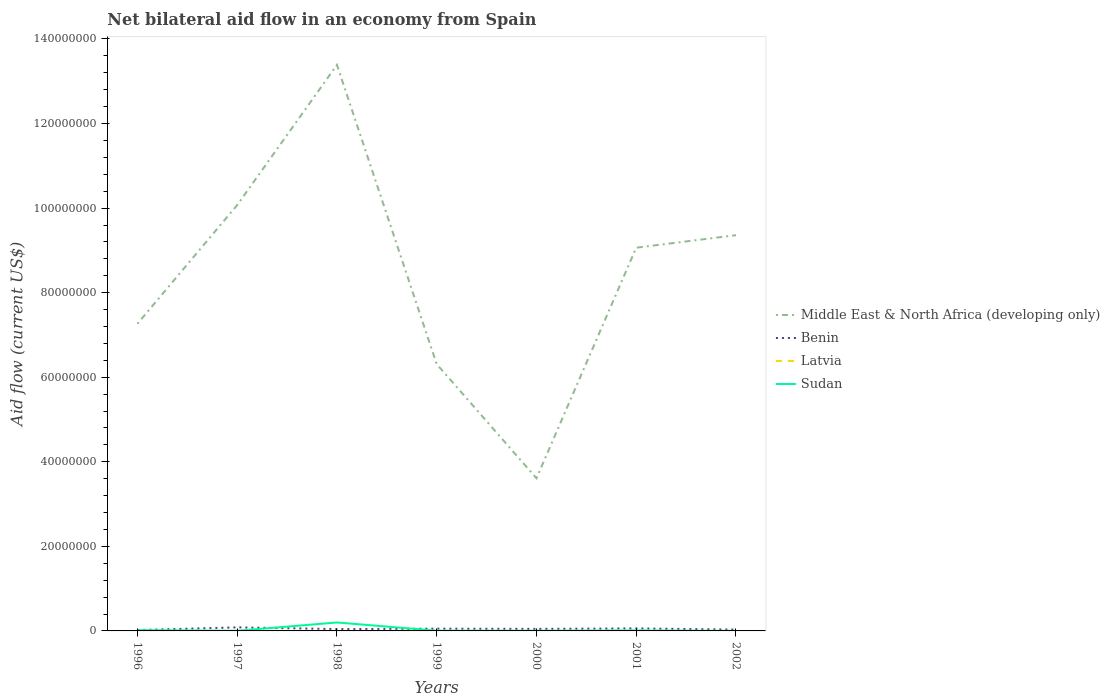How many different coloured lines are there?
Ensure brevity in your answer.  4. Across all years, what is the maximum net bilateral aid flow in Latvia?
Offer a very short reply. 10000. What is the total net bilateral aid flow in Middle East & North Africa (developing only) in the graph?
Offer a very short reply. 4.32e+07. What is the difference between the highest and the second highest net bilateral aid flow in Benin?
Offer a very short reply. 6.40e+05. How many lines are there?
Ensure brevity in your answer.  4. How many years are there in the graph?
Make the answer very short. 7. Does the graph contain grids?
Your answer should be very brief. No. Where does the legend appear in the graph?
Your response must be concise. Center right. What is the title of the graph?
Ensure brevity in your answer.  Net bilateral aid flow in an economy from Spain. Does "Central African Republic" appear as one of the legend labels in the graph?
Your response must be concise. No. What is the label or title of the X-axis?
Make the answer very short. Years. What is the label or title of the Y-axis?
Ensure brevity in your answer.  Aid flow (current US$). What is the Aid flow (current US$) in Middle East & North Africa (developing only) in 1996?
Your response must be concise. 7.26e+07. What is the Aid flow (current US$) in Sudan in 1996?
Offer a terse response. 1.80e+05. What is the Aid flow (current US$) in Middle East & North Africa (developing only) in 1997?
Your response must be concise. 1.01e+08. What is the Aid flow (current US$) of Benin in 1997?
Your response must be concise. 8.40e+05. What is the Aid flow (current US$) in Latvia in 1997?
Offer a terse response. 10000. What is the Aid flow (current US$) of Middle East & North Africa (developing only) in 1998?
Give a very brief answer. 1.34e+08. What is the Aid flow (current US$) of Latvia in 1998?
Give a very brief answer. 10000. What is the Aid flow (current US$) of Sudan in 1998?
Ensure brevity in your answer.  2.00e+06. What is the Aid flow (current US$) of Middle East & North Africa (developing only) in 1999?
Offer a very short reply. 6.31e+07. What is the Aid flow (current US$) of Benin in 1999?
Offer a terse response. 5.30e+05. What is the Aid flow (current US$) of Middle East & North Africa (developing only) in 2000?
Offer a terse response. 3.61e+07. What is the Aid flow (current US$) of Benin in 2000?
Keep it short and to the point. 4.80e+05. What is the Aid flow (current US$) of Sudan in 2000?
Provide a short and direct response. 4.00e+04. What is the Aid flow (current US$) of Middle East & North Africa (developing only) in 2001?
Provide a short and direct response. 9.06e+07. What is the Aid flow (current US$) in Benin in 2001?
Provide a succinct answer. 5.90e+05. What is the Aid flow (current US$) in Latvia in 2001?
Offer a very short reply. 2.00e+04. What is the Aid flow (current US$) in Middle East & North Africa (developing only) in 2002?
Your response must be concise. 9.36e+07. What is the Aid flow (current US$) of Benin in 2002?
Provide a succinct answer. 3.20e+05. What is the Aid flow (current US$) in Sudan in 2002?
Provide a short and direct response. 10000. Across all years, what is the maximum Aid flow (current US$) in Middle East & North Africa (developing only)?
Your answer should be very brief. 1.34e+08. Across all years, what is the maximum Aid flow (current US$) in Benin?
Ensure brevity in your answer.  8.40e+05. Across all years, what is the maximum Aid flow (current US$) of Latvia?
Give a very brief answer. 2.00e+04. Across all years, what is the minimum Aid flow (current US$) of Middle East & North Africa (developing only)?
Your answer should be compact. 3.61e+07. Across all years, what is the minimum Aid flow (current US$) of Sudan?
Provide a succinct answer. 10000. What is the total Aid flow (current US$) in Middle East & North Africa (developing only) in the graph?
Your answer should be very brief. 5.91e+08. What is the total Aid flow (current US$) in Benin in the graph?
Your answer should be very brief. 3.39e+06. What is the total Aid flow (current US$) in Sudan in the graph?
Ensure brevity in your answer.  2.41e+06. What is the difference between the Aid flow (current US$) of Middle East & North Africa (developing only) in 1996 and that in 1997?
Ensure brevity in your answer.  -2.81e+07. What is the difference between the Aid flow (current US$) of Benin in 1996 and that in 1997?
Keep it short and to the point. -6.40e+05. What is the difference between the Aid flow (current US$) of Latvia in 1996 and that in 1997?
Provide a succinct answer. 0. What is the difference between the Aid flow (current US$) in Sudan in 1996 and that in 1997?
Your answer should be compact. 1.50e+05. What is the difference between the Aid flow (current US$) of Middle East & North Africa (developing only) in 1996 and that in 1998?
Keep it short and to the point. -6.12e+07. What is the difference between the Aid flow (current US$) in Benin in 1996 and that in 1998?
Provide a succinct answer. -2.30e+05. What is the difference between the Aid flow (current US$) in Latvia in 1996 and that in 1998?
Your response must be concise. 0. What is the difference between the Aid flow (current US$) in Sudan in 1996 and that in 1998?
Offer a very short reply. -1.82e+06. What is the difference between the Aid flow (current US$) of Middle East & North Africa (developing only) in 1996 and that in 1999?
Offer a very short reply. 9.55e+06. What is the difference between the Aid flow (current US$) of Benin in 1996 and that in 1999?
Provide a succinct answer. -3.30e+05. What is the difference between the Aid flow (current US$) in Sudan in 1996 and that in 1999?
Provide a short and direct response. 1.30e+05. What is the difference between the Aid flow (current US$) in Middle East & North Africa (developing only) in 1996 and that in 2000?
Keep it short and to the point. 3.65e+07. What is the difference between the Aid flow (current US$) in Benin in 1996 and that in 2000?
Give a very brief answer. -2.80e+05. What is the difference between the Aid flow (current US$) of Latvia in 1996 and that in 2000?
Give a very brief answer. 0. What is the difference between the Aid flow (current US$) of Middle East & North Africa (developing only) in 1996 and that in 2001?
Your response must be concise. -1.80e+07. What is the difference between the Aid flow (current US$) of Benin in 1996 and that in 2001?
Offer a terse response. -3.90e+05. What is the difference between the Aid flow (current US$) of Latvia in 1996 and that in 2001?
Keep it short and to the point. -10000. What is the difference between the Aid flow (current US$) in Middle East & North Africa (developing only) in 1996 and that in 2002?
Your response must be concise. -2.10e+07. What is the difference between the Aid flow (current US$) in Middle East & North Africa (developing only) in 1997 and that in 1998?
Provide a short and direct response. -3.32e+07. What is the difference between the Aid flow (current US$) in Benin in 1997 and that in 1998?
Your answer should be compact. 4.10e+05. What is the difference between the Aid flow (current US$) in Sudan in 1997 and that in 1998?
Offer a terse response. -1.97e+06. What is the difference between the Aid flow (current US$) of Middle East & North Africa (developing only) in 1997 and that in 1999?
Your answer should be very brief. 3.76e+07. What is the difference between the Aid flow (current US$) of Benin in 1997 and that in 1999?
Offer a terse response. 3.10e+05. What is the difference between the Aid flow (current US$) of Middle East & North Africa (developing only) in 1997 and that in 2000?
Your answer should be compact. 6.46e+07. What is the difference between the Aid flow (current US$) of Middle East & North Africa (developing only) in 1997 and that in 2001?
Provide a succinct answer. 1.01e+07. What is the difference between the Aid flow (current US$) in Latvia in 1997 and that in 2001?
Provide a succinct answer. -10000. What is the difference between the Aid flow (current US$) in Sudan in 1997 and that in 2001?
Your answer should be very brief. -7.00e+04. What is the difference between the Aid flow (current US$) in Middle East & North Africa (developing only) in 1997 and that in 2002?
Your answer should be very brief. 7.12e+06. What is the difference between the Aid flow (current US$) in Benin in 1997 and that in 2002?
Your answer should be compact. 5.20e+05. What is the difference between the Aid flow (current US$) in Sudan in 1997 and that in 2002?
Your answer should be very brief. 2.00e+04. What is the difference between the Aid flow (current US$) of Middle East & North Africa (developing only) in 1998 and that in 1999?
Give a very brief answer. 7.08e+07. What is the difference between the Aid flow (current US$) of Benin in 1998 and that in 1999?
Your answer should be compact. -1.00e+05. What is the difference between the Aid flow (current US$) in Sudan in 1998 and that in 1999?
Make the answer very short. 1.95e+06. What is the difference between the Aid flow (current US$) of Middle East & North Africa (developing only) in 1998 and that in 2000?
Your response must be concise. 9.78e+07. What is the difference between the Aid flow (current US$) of Sudan in 1998 and that in 2000?
Your answer should be very brief. 1.96e+06. What is the difference between the Aid flow (current US$) in Middle East & North Africa (developing only) in 1998 and that in 2001?
Make the answer very short. 4.32e+07. What is the difference between the Aid flow (current US$) in Benin in 1998 and that in 2001?
Make the answer very short. -1.60e+05. What is the difference between the Aid flow (current US$) in Latvia in 1998 and that in 2001?
Provide a short and direct response. -10000. What is the difference between the Aid flow (current US$) of Sudan in 1998 and that in 2001?
Your response must be concise. 1.90e+06. What is the difference between the Aid flow (current US$) of Middle East & North Africa (developing only) in 1998 and that in 2002?
Provide a succinct answer. 4.03e+07. What is the difference between the Aid flow (current US$) in Benin in 1998 and that in 2002?
Offer a terse response. 1.10e+05. What is the difference between the Aid flow (current US$) in Latvia in 1998 and that in 2002?
Provide a succinct answer. 0. What is the difference between the Aid flow (current US$) in Sudan in 1998 and that in 2002?
Your answer should be compact. 1.99e+06. What is the difference between the Aid flow (current US$) of Middle East & North Africa (developing only) in 1999 and that in 2000?
Provide a short and direct response. 2.70e+07. What is the difference between the Aid flow (current US$) of Latvia in 1999 and that in 2000?
Keep it short and to the point. 0. What is the difference between the Aid flow (current US$) in Middle East & North Africa (developing only) in 1999 and that in 2001?
Your response must be concise. -2.75e+07. What is the difference between the Aid flow (current US$) of Benin in 1999 and that in 2001?
Keep it short and to the point. -6.00e+04. What is the difference between the Aid flow (current US$) of Latvia in 1999 and that in 2001?
Make the answer very short. -10000. What is the difference between the Aid flow (current US$) of Middle East & North Africa (developing only) in 1999 and that in 2002?
Your answer should be compact. -3.05e+07. What is the difference between the Aid flow (current US$) in Benin in 1999 and that in 2002?
Your answer should be very brief. 2.10e+05. What is the difference between the Aid flow (current US$) of Sudan in 1999 and that in 2002?
Offer a very short reply. 4.00e+04. What is the difference between the Aid flow (current US$) in Middle East & North Africa (developing only) in 2000 and that in 2001?
Keep it short and to the point. -5.45e+07. What is the difference between the Aid flow (current US$) in Latvia in 2000 and that in 2001?
Provide a succinct answer. -10000. What is the difference between the Aid flow (current US$) of Middle East & North Africa (developing only) in 2000 and that in 2002?
Offer a terse response. -5.75e+07. What is the difference between the Aid flow (current US$) of Benin in 2000 and that in 2002?
Offer a very short reply. 1.60e+05. What is the difference between the Aid flow (current US$) of Sudan in 2000 and that in 2002?
Offer a very short reply. 3.00e+04. What is the difference between the Aid flow (current US$) in Middle East & North Africa (developing only) in 2001 and that in 2002?
Offer a very short reply. -2.96e+06. What is the difference between the Aid flow (current US$) in Benin in 2001 and that in 2002?
Give a very brief answer. 2.70e+05. What is the difference between the Aid flow (current US$) in Middle East & North Africa (developing only) in 1996 and the Aid flow (current US$) in Benin in 1997?
Keep it short and to the point. 7.18e+07. What is the difference between the Aid flow (current US$) of Middle East & North Africa (developing only) in 1996 and the Aid flow (current US$) of Latvia in 1997?
Your answer should be compact. 7.26e+07. What is the difference between the Aid flow (current US$) in Middle East & North Africa (developing only) in 1996 and the Aid flow (current US$) in Sudan in 1997?
Keep it short and to the point. 7.26e+07. What is the difference between the Aid flow (current US$) in Benin in 1996 and the Aid flow (current US$) in Sudan in 1997?
Offer a terse response. 1.70e+05. What is the difference between the Aid flow (current US$) in Latvia in 1996 and the Aid flow (current US$) in Sudan in 1997?
Ensure brevity in your answer.  -2.00e+04. What is the difference between the Aid flow (current US$) in Middle East & North Africa (developing only) in 1996 and the Aid flow (current US$) in Benin in 1998?
Your answer should be very brief. 7.22e+07. What is the difference between the Aid flow (current US$) in Middle East & North Africa (developing only) in 1996 and the Aid flow (current US$) in Latvia in 1998?
Your answer should be very brief. 7.26e+07. What is the difference between the Aid flow (current US$) in Middle East & North Africa (developing only) in 1996 and the Aid flow (current US$) in Sudan in 1998?
Offer a very short reply. 7.06e+07. What is the difference between the Aid flow (current US$) of Benin in 1996 and the Aid flow (current US$) of Latvia in 1998?
Provide a succinct answer. 1.90e+05. What is the difference between the Aid flow (current US$) in Benin in 1996 and the Aid flow (current US$) in Sudan in 1998?
Ensure brevity in your answer.  -1.80e+06. What is the difference between the Aid flow (current US$) of Latvia in 1996 and the Aid flow (current US$) of Sudan in 1998?
Your response must be concise. -1.99e+06. What is the difference between the Aid flow (current US$) in Middle East & North Africa (developing only) in 1996 and the Aid flow (current US$) in Benin in 1999?
Your answer should be compact. 7.21e+07. What is the difference between the Aid flow (current US$) of Middle East & North Africa (developing only) in 1996 and the Aid flow (current US$) of Latvia in 1999?
Provide a short and direct response. 7.26e+07. What is the difference between the Aid flow (current US$) in Middle East & North Africa (developing only) in 1996 and the Aid flow (current US$) in Sudan in 1999?
Give a very brief answer. 7.26e+07. What is the difference between the Aid flow (current US$) in Benin in 1996 and the Aid flow (current US$) in Sudan in 1999?
Your answer should be compact. 1.50e+05. What is the difference between the Aid flow (current US$) in Middle East & North Africa (developing only) in 1996 and the Aid flow (current US$) in Benin in 2000?
Your answer should be very brief. 7.22e+07. What is the difference between the Aid flow (current US$) in Middle East & North Africa (developing only) in 1996 and the Aid flow (current US$) in Latvia in 2000?
Offer a terse response. 7.26e+07. What is the difference between the Aid flow (current US$) of Middle East & North Africa (developing only) in 1996 and the Aid flow (current US$) of Sudan in 2000?
Your response must be concise. 7.26e+07. What is the difference between the Aid flow (current US$) of Middle East & North Africa (developing only) in 1996 and the Aid flow (current US$) of Benin in 2001?
Make the answer very short. 7.21e+07. What is the difference between the Aid flow (current US$) in Middle East & North Africa (developing only) in 1996 and the Aid flow (current US$) in Latvia in 2001?
Provide a succinct answer. 7.26e+07. What is the difference between the Aid flow (current US$) of Middle East & North Africa (developing only) in 1996 and the Aid flow (current US$) of Sudan in 2001?
Give a very brief answer. 7.26e+07. What is the difference between the Aid flow (current US$) of Latvia in 1996 and the Aid flow (current US$) of Sudan in 2001?
Offer a terse response. -9.00e+04. What is the difference between the Aid flow (current US$) in Middle East & North Africa (developing only) in 1996 and the Aid flow (current US$) in Benin in 2002?
Provide a short and direct response. 7.23e+07. What is the difference between the Aid flow (current US$) in Middle East & North Africa (developing only) in 1996 and the Aid flow (current US$) in Latvia in 2002?
Your answer should be compact. 7.26e+07. What is the difference between the Aid flow (current US$) in Middle East & North Africa (developing only) in 1996 and the Aid flow (current US$) in Sudan in 2002?
Provide a short and direct response. 7.26e+07. What is the difference between the Aid flow (current US$) of Benin in 1996 and the Aid flow (current US$) of Sudan in 2002?
Ensure brevity in your answer.  1.90e+05. What is the difference between the Aid flow (current US$) of Middle East & North Africa (developing only) in 1997 and the Aid flow (current US$) of Benin in 1998?
Your response must be concise. 1.00e+08. What is the difference between the Aid flow (current US$) of Middle East & North Africa (developing only) in 1997 and the Aid flow (current US$) of Latvia in 1998?
Your response must be concise. 1.01e+08. What is the difference between the Aid flow (current US$) of Middle East & North Africa (developing only) in 1997 and the Aid flow (current US$) of Sudan in 1998?
Make the answer very short. 9.87e+07. What is the difference between the Aid flow (current US$) of Benin in 1997 and the Aid flow (current US$) of Latvia in 1998?
Provide a short and direct response. 8.30e+05. What is the difference between the Aid flow (current US$) in Benin in 1997 and the Aid flow (current US$) in Sudan in 1998?
Provide a short and direct response. -1.16e+06. What is the difference between the Aid flow (current US$) of Latvia in 1997 and the Aid flow (current US$) of Sudan in 1998?
Provide a succinct answer. -1.99e+06. What is the difference between the Aid flow (current US$) of Middle East & North Africa (developing only) in 1997 and the Aid flow (current US$) of Benin in 1999?
Your response must be concise. 1.00e+08. What is the difference between the Aid flow (current US$) of Middle East & North Africa (developing only) in 1997 and the Aid flow (current US$) of Latvia in 1999?
Offer a terse response. 1.01e+08. What is the difference between the Aid flow (current US$) in Middle East & North Africa (developing only) in 1997 and the Aid flow (current US$) in Sudan in 1999?
Offer a very short reply. 1.01e+08. What is the difference between the Aid flow (current US$) in Benin in 1997 and the Aid flow (current US$) in Latvia in 1999?
Provide a short and direct response. 8.30e+05. What is the difference between the Aid flow (current US$) in Benin in 1997 and the Aid flow (current US$) in Sudan in 1999?
Your response must be concise. 7.90e+05. What is the difference between the Aid flow (current US$) in Middle East & North Africa (developing only) in 1997 and the Aid flow (current US$) in Benin in 2000?
Make the answer very short. 1.00e+08. What is the difference between the Aid flow (current US$) in Middle East & North Africa (developing only) in 1997 and the Aid flow (current US$) in Latvia in 2000?
Give a very brief answer. 1.01e+08. What is the difference between the Aid flow (current US$) in Middle East & North Africa (developing only) in 1997 and the Aid flow (current US$) in Sudan in 2000?
Give a very brief answer. 1.01e+08. What is the difference between the Aid flow (current US$) in Benin in 1997 and the Aid flow (current US$) in Latvia in 2000?
Give a very brief answer. 8.30e+05. What is the difference between the Aid flow (current US$) in Middle East & North Africa (developing only) in 1997 and the Aid flow (current US$) in Benin in 2001?
Provide a short and direct response. 1.00e+08. What is the difference between the Aid flow (current US$) in Middle East & North Africa (developing only) in 1997 and the Aid flow (current US$) in Latvia in 2001?
Keep it short and to the point. 1.01e+08. What is the difference between the Aid flow (current US$) in Middle East & North Africa (developing only) in 1997 and the Aid flow (current US$) in Sudan in 2001?
Keep it short and to the point. 1.01e+08. What is the difference between the Aid flow (current US$) in Benin in 1997 and the Aid flow (current US$) in Latvia in 2001?
Give a very brief answer. 8.20e+05. What is the difference between the Aid flow (current US$) of Benin in 1997 and the Aid flow (current US$) of Sudan in 2001?
Provide a short and direct response. 7.40e+05. What is the difference between the Aid flow (current US$) of Latvia in 1997 and the Aid flow (current US$) of Sudan in 2001?
Ensure brevity in your answer.  -9.00e+04. What is the difference between the Aid flow (current US$) in Middle East & North Africa (developing only) in 1997 and the Aid flow (current US$) in Benin in 2002?
Your answer should be compact. 1.00e+08. What is the difference between the Aid flow (current US$) of Middle East & North Africa (developing only) in 1997 and the Aid flow (current US$) of Latvia in 2002?
Your answer should be compact. 1.01e+08. What is the difference between the Aid flow (current US$) of Middle East & North Africa (developing only) in 1997 and the Aid flow (current US$) of Sudan in 2002?
Your answer should be very brief. 1.01e+08. What is the difference between the Aid flow (current US$) in Benin in 1997 and the Aid flow (current US$) in Latvia in 2002?
Ensure brevity in your answer.  8.30e+05. What is the difference between the Aid flow (current US$) of Benin in 1997 and the Aid flow (current US$) of Sudan in 2002?
Your answer should be very brief. 8.30e+05. What is the difference between the Aid flow (current US$) in Middle East & North Africa (developing only) in 1998 and the Aid flow (current US$) in Benin in 1999?
Offer a very short reply. 1.33e+08. What is the difference between the Aid flow (current US$) of Middle East & North Africa (developing only) in 1998 and the Aid flow (current US$) of Latvia in 1999?
Your answer should be very brief. 1.34e+08. What is the difference between the Aid flow (current US$) of Middle East & North Africa (developing only) in 1998 and the Aid flow (current US$) of Sudan in 1999?
Make the answer very short. 1.34e+08. What is the difference between the Aid flow (current US$) in Latvia in 1998 and the Aid flow (current US$) in Sudan in 1999?
Offer a terse response. -4.00e+04. What is the difference between the Aid flow (current US$) of Middle East & North Africa (developing only) in 1998 and the Aid flow (current US$) of Benin in 2000?
Offer a very short reply. 1.33e+08. What is the difference between the Aid flow (current US$) of Middle East & North Africa (developing only) in 1998 and the Aid flow (current US$) of Latvia in 2000?
Make the answer very short. 1.34e+08. What is the difference between the Aid flow (current US$) in Middle East & North Africa (developing only) in 1998 and the Aid flow (current US$) in Sudan in 2000?
Keep it short and to the point. 1.34e+08. What is the difference between the Aid flow (current US$) of Latvia in 1998 and the Aid flow (current US$) of Sudan in 2000?
Provide a succinct answer. -3.00e+04. What is the difference between the Aid flow (current US$) of Middle East & North Africa (developing only) in 1998 and the Aid flow (current US$) of Benin in 2001?
Your answer should be compact. 1.33e+08. What is the difference between the Aid flow (current US$) in Middle East & North Africa (developing only) in 1998 and the Aid flow (current US$) in Latvia in 2001?
Provide a succinct answer. 1.34e+08. What is the difference between the Aid flow (current US$) in Middle East & North Africa (developing only) in 1998 and the Aid flow (current US$) in Sudan in 2001?
Give a very brief answer. 1.34e+08. What is the difference between the Aid flow (current US$) in Benin in 1998 and the Aid flow (current US$) in Latvia in 2001?
Your response must be concise. 4.10e+05. What is the difference between the Aid flow (current US$) of Middle East & North Africa (developing only) in 1998 and the Aid flow (current US$) of Benin in 2002?
Give a very brief answer. 1.34e+08. What is the difference between the Aid flow (current US$) of Middle East & North Africa (developing only) in 1998 and the Aid flow (current US$) of Latvia in 2002?
Your response must be concise. 1.34e+08. What is the difference between the Aid flow (current US$) of Middle East & North Africa (developing only) in 1998 and the Aid flow (current US$) of Sudan in 2002?
Your answer should be compact. 1.34e+08. What is the difference between the Aid flow (current US$) in Benin in 1998 and the Aid flow (current US$) in Latvia in 2002?
Your answer should be very brief. 4.20e+05. What is the difference between the Aid flow (current US$) of Benin in 1998 and the Aid flow (current US$) of Sudan in 2002?
Your answer should be compact. 4.20e+05. What is the difference between the Aid flow (current US$) of Latvia in 1998 and the Aid flow (current US$) of Sudan in 2002?
Offer a very short reply. 0. What is the difference between the Aid flow (current US$) of Middle East & North Africa (developing only) in 1999 and the Aid flow (current US$) of Benin in 2000?
Offer a terse response. 6.26e+07. What is the difference between the Aid flow (current US$) of Middle East & North Africa (developing only) in 1999 and the Aid flow (current US$) of Latvia in 2000?
Ensure brevity in your answer.  6.31e+07. What is the difference between the Aid flow (current US$) in Middle East & North Africa (developing only) in 1999 and the Aid flow (current US$) in Sudan in 2000?
Ensure brevity in your answer.  6.31e+07. What is the difference between the Aid flow (current US$) in Benin in 1999 and the Aid flow (current US$) in Latvia in 2000?
Your answer should be very brief. 5.20e+05. What is the difference between the Aid flow (current US$) in Middle East & North Africa (developing only) in 1999 and the Aid flow (current US$) in Benin in 2001?
Give a very brief answer. 6.25e+07. What is the difference between the Aid flow (current US$) of Middle East & North Africa (developing only) in 1999 and the Aid flow (current US$) of Latvia in 2001?
Ensure brevity in your answer.  6.31e+07. What is the difference between the Aid flow (current US$) of Middle East & North Africa (developing only) in 1999 and the Aid flow (current US$) of Sudan in 2001?
Provide a short and direct response. 6.30e+07. What is the difference between the Aid flow (current US$) of Benin in 1999 and the Aid flow (current US$) of Latvia in 2001?
Offer a terse response. 5.10e+05. What is the difference between the Aid flow (current US$) of Benin in 1999 and the Aid flow (current US$) of Sudan in 2001?
Give a very brief answer. 4.30e+05. What is the difference between the Aid flow (current US$) in Middle East & North Africa (developing only) in 1999 and the Aid flow (current US$) in Benin in 2002?
Offer a very short reply. 6.28e+07. What is the difference between the Aid flow (current US$) of Middle East & North Africa (developing only) in 1999 and the Aid flow (current US$) of Latvia in 2002?
Your response must be concise. 6.31e+07. What is the difference between the Aid flow (current US$) in Middle East & North Africa (developing only) in 1999 and the Aid flow (current US$) in Sudan in 2002?
Provide a short and direct response. 6.31e+07. What is the difference between the Aid flow (current US$) in Benin in 1999 and the Aid flow (current US$) in Latvia in 2002?
Offer a very short reply. 5.20e+05. What is the difference between the Aid flow (current US$) in Benin in 1999 and the Aid flow (current US$) in Sudan in 2002?
Offer a very short reply. 5.20e+05. What is the difference between the Aid flow (current US$) of Latvia in 1999 and the Aid flow (current US$) of Sudan in 2002?
Give a very brief answer. 0. What is the difference between the Aid flow (current US$) in Middle East & North Africa (developing only) in 2000 and the Aid flow (current US$) in Benin in 2001?
Your answer should be compact. 3.55e+07. What is the difference between the Aid flow (current US$) in Middle East & North Africa (developing only) in 2000 and the Aid flow (current US$) in Latvia in 2001?
Make the answer very short. 3.61e+07. What is the difference between the Aid flow (current US$) of Middle East & North Africa (developing only) in 2000 and the Aid flow (current US$) of Sudan in 2001?
Your response must be concise. 3.60e+07. What is the difference between the Aid flow (current US$) of Middle East & North Africa (developing only) in 2000 and the Aid flow (current US$) of Benin in 2002?
Ensure brevity in your answer.  3.58e+07. What is the difference between the Aid flow (current US$) in Middle East & North Africa (developing only) in 2000 and the Aid flow (current US$) in Latvia in 2002?
Your response must be concise. 3.61e+07. What is the difference between the Aid flow (current US$) in Middle East & North Africa (developing only) in 2000 and the Aid flow (current US$) in Sudan in 2002?
Your answer should be compact. 3.61e+07. What is the difference between the Aid flow (current US$) of Benin in 2000 and the Aid flow (current US$) of Latvia in 2002?
Offer a very short reply. 4.70e+05. What is the difference between the Aid flow (current US$) in Benin in 2000 and the Aid flow (current US$) in Sudan in 2002?
Keep it short and to the point. 4.70e+05. What is the difference between the Aid flow (current US$) of Middle East & North Africa (developing only) in 2001 and the Aid flow (current US$) of Benin in 2002?
Keep it short and to the point. 9.03e+07. What is the difference between the Aid flow (current US$) in Middle East & North Africa (developing only) in 2001 and the Aid flow (current US$) in Latvia in 2002?
Your answer should be compact. 9.06e+07. What is the difference between the Aid flow (current US$) of Middle East & North Africa (developing only) in 2001 and the Aid flow (current US$) of Sudan in 2002?
Offer a very short reply. 9.06e+07. What is the difference between the Aid flow (current US$) of Benin in 2001 and the Aid flow (current US$) of Latvia in 2002?
Your answer should be very brief. 5.80e+05. What is the difference between the Aid flow (current US$) of Benin in 2001 and the Aid flow (current US$) of Sudan in 2002?
Provide a short and direct response. 5.80e+05. What is the average Aid flow (current US$) of Middle East & North Africa (developing only) per year?
Keep it short and to the point. 8.44e+07. What is the average Aid flow (current US$) of Benin per year?
Provide a short and direct response. 4.84e+05. What is the average Aid flow (current US$) of Latvia per year?
Keep it short and to the point. 1.14e+04. What is the average Aid flow (current US$) in Sudan per year?
Keep it short and to the point. 3.44e+05. In the year 1996, what is the difference between the Aid flow (current US$) in Middle East & North Africa (developing only) and Aid flow (current US$) in Benin?
Ensure brevity in your answer.  7.24e+07. In the year 1996, what is the difference between the Aid flow (current US$) of Middle East & North Africa (developing only) and Aid flow (current US$) of Latvia?
Offer a very short reply. 7.26e+07. In the year 1996, what is the difference between the Aid flow (current US$) of Middle East & North Africa (developing only) and Aid flow (current US$) of Sudan?
Offer a terse response. 7.25e+07. In the year 1996, what is the difference between the Aid flow (current US$) of Latvia and Aid flow (current US$) of Sudan?
Your response must be concise. -1.70e+05. In the year 1997, what is the difference between the Aid flow (current US$) in Middle East & North Africa (developing only) and Aid flow (current US$) in Benin?
Keep it short and to the point. 9.99e+07. In the year 1997, what is the difference between the Aid flow (current US$) of Middle East & North Africa (developing only) and Aid flow (current US$) of Latvia?
Offer a terse response. 1.01e+08. In the year 1997, what is the difference between the Aid flow (current US$) in Middle East & North Africa (developing only) and Aid flow (current US$) in Sudan?
Keep it short and to the point. 1.01e+08. In the year 1997, what is the difference between the Aid flow (current US$) of Benin and Aid flow (current US$) of Latvia?
Provide a succinct answer. 8.30e+05. In the year 1997, what is the difference between the Aid flow (current US$) of Benin and Aid flow (current US$) of Sudan?
Keep it short and to the point. 8.10e+05. In the year 1998, what is the difference between the Aid flow (current US$) of Middle East & North Africa (developing only) and Aid flow (current US$) of Benin?
Give a very brief answer. 1.33e+08. In the year 1998, what is the difference between the Aid flow (current US$) in Middle East & North Africa (developing only) and Aid flow (current US$) in Latvia?
Keep it short and to the point. 1.34e+08. In the year 1998, what is the difference between the Aid flow (current US$) in Middle East & North Africa (developing only) and Aid flow (current US$) in Sudan?
Provide a short and direct response. 1.32e+08. In the year 1998, what is the difference between the Aid flow (current US$) in Benin and Aid flow (current US$) in Sudan?
Offer a very short reply. -1.57e+06. In the year 1998, what is the difference between the Aid flow (current US$) of Latvia and Aid flow (current US$) of Sudan?
Make the answer very short. -1.99e+06. In the year 1999, what is the difference between the Aid flow (current US$) of Middle East & North Africa (developing only) and Aid flow (current US$) of Benin?
Ensure brevity in your answer.  6.26e+07. In the year 1999, what is the difference between the Aid flow (current US$) in Middle East & North Africa (developing only) and Aid flow (current US$) in Latvia?
Your response must be concise. 6.31e+07. In the year 1999, what is the difference between the Aid flow (current US$) in Middle East & North Africa (developing only) and Aid flow (current US$) in Sudan?
Make the answer very short. 6.30e+07. In the year 1999, what is the difference between the Aid flow (current US$) of Benin and Aid flow (current US$) of Latvia?
Make the answer very short. 5.20e+05. In the year 1999, what is the difference between the Aid flow (current US$) of Latvia and Aid flow (current US$) of Sudan?
Give a very brief answer. -4.00e+04. In the year 2000, what is the difference between the Aid flow (current US$) in Middle East & North Africa (developing only) and Aid flow (current US$) in Benin?
Make the answer very short. 3.56e+07. In the year 2000, what is the difference between the Aid flow (current US$) of Middle East & North Africa (developing only) and Aid flow (current US$) of Latvia?
Provide a short and direct response. 3.61e+07. In the year 2000, what is the difference between the Aid flow (current US$) of Middle East & North Africa (developing only) and Aid flow (current US$) of Sudan?
Your answer should be compact. 3.61e+07. In the year 2000, what is the difference between the Aid flow (current US$) in Benin and Aid flow (current US$) in Latvia?
Provide a succinct answer. 4.70e+05. In the year 2000, what is the difference between the Aid flow (current US$) of Benin and Aid flow (current US$) of Sudan?
Your answer should be compact. 4.40e+05. In the year 2000, what is the difference between the Aid flow (current US$) in Latvia and Aid flow (current US$) in Sudan?
Give a very brief answer. -3.00e+04. In the year 2001, what is the difference between the Aid flow (current US$) in Middle East & North Africa (developing only) and Aid flow (current US$) in Benin?
Give a very brief answer. 9.00e+07. In the year 2001, what is the difference between the Aid flow (current US$) of Middle East & North Africa (developing only) and Aid flow (current US$) of Latvia?
Your answer should be compact. 9.06e+07. In the year 2001, what is the difference between the Aid flow (current US$) in Middle East & North Africa (developing only) and Aid flow (current US$) in Sudan?
Your response must be concise. 9.05e+07. In the year 2001, what is the difference between the Aid flow (current US$) of Benin and Aid flow (current US$) of Latvia?
Ensure brevity in your answer.  5.70e+05. In the year 2002, what is the difference between the Aid flow (current US$) of Middle East & North Africa (developing only) and Aid flow (current US$) of Benin?
Ensure brevity in your answer.  9.33e+07. In the year 2002, what is the difference between the Aid flow (current US$) in Middle East & North Africa (developing only) and Aid flow (current US$) in Latvia?
Provide a short and direct response. 9.36e+07. In the year 2002, what is the difference between the Aid flow (current US$) in Middle East & North Africa (developing only) and Aid flow (current US$) in Sudan?
Make the answer very short. 9.36e+07. In the year 2002, what is the difference between the Aid flow (current US$) of Benin and Aid flow (current US$) of Latvia?
Offer a very short reply. 3.10e+05. In the year 2002, what is the difference between the Aid flow (current US$) of Benin and Aid flow (current US$) of Sudan?
Keep it short and to the point. 3.10e+05. What is the ratio of the Aid flow (current US$) of Middle East & North Africa (developing only) in 1996 to that in 1997?
Provide a short and direct response. 0.72. What is the ratio of the Aid flow (current US$) of Benin in 1996 to that in 1997?
Provide a short and direct response. 0.24. What is the ratio of the Aid flow (current US$) of Latvia in 1996 to that in 1997?
Make the answer very short. 1. What is the ratio of the Aid flow (current US$) of Middle East & North Africa (developing only) in 1996 to that in 1998?
Your answer should be very brief. 0.54. What is the ratio of the Aid flow (current US$) of Benin in 1996 to that in 1998?
Provide a short and direct response. 0.47. What is the ratio of the Aid flow (current US$) in Sudan in 1996 to that in 1998?
Your answer should be very brief. 0.09. What is the ratio of the Aid flow (current US$) in Middle East & North Africa (developing only) in 1996 to that in 1999?
Offer a very short reply. 1.15. What is the ratio of the Aid flow (current US$) in Benin in 1996 to that in 1999?
Your answer should be very brief. 0.38. What is the ratio of the Aid flow (current US$) in Sudan in 1996 to that in 1999?
Give a very brief answer. 3.6. What is the ratio of the Aid flow (current US$) in Middle East & North Africa (developing only) in 1996 to that in 2000?
Ensure brevity in your answer.  2.01. What is the ratio of the Aid flow (current US$) of Benin in 1996 to that in 2000?
Keep it short and to the point. 0.42. What is the ratio of the Aid flow (current US$) in Latvia in 1996 to that in 2000?
Your response must be concise. 1. What is the ratio of the Aid flow (current US$) in Middle East & North Africa (developing only) in 1996 to that in 2001?
Keep it short and to the point. 0.8. What is the ratio of the Aid flow (current US$) in Benin in 1996 to that in 2001?
Make the answer very short. 0.34. What is the ratio of the Aid flow (current US$) of Sudan in 1996 to that in 2001?
Your response must be concise. 1.8. What is the ratio of the Aid flow (current US$) of Middle East & North Africa (developing only) in 1996 to that in 2002?
Provide a succinct answer. 0.78. What is the ratio of the Aid flow (current US$) in Benin in 1996 to that in 2002?
Your answer should be very brief. 0.62. What is the ratio of the Aid flow (current US$) of Middle East & North Africa (developing only) in 1997 to that in 1998?
Ensure brevity in your answer.  0.75. What is the ratio of the Aid flow (current US$) of Benin in 1997 to that in 1998?
Provide a short and direct response. 1.95. What is the ratio of the Aid flow (current US$) of Latvia in 1997 to that in 1998?
Make the answer very short. 1. What is the ratio of the Aid flow (current US$) in Sudan in 1997 to that in 1998?
Give a very brief answer. 0.01. What is the ratio of the Aid flow (current US$) of Middle East & North Africa (developing only) in 1997 to that in 1999?
Give a very brief answer. 1.6. What is the ratio of the Aid flow (current US$) in Benin in 1997 to that in 1999?
Ensure brevity in your answer.  1.58. What is the ratio of the Aid flow (current US$) of Latvia in 1997 to that in 1999?
Offer a terse response. 1. What is the ratio of the Aid flow (current US$) in Middle East & North Africa (developing only) in 1997 to that in 2000?
Ensure brevity in your answer.  2.79. What is the ratio of the Aid flow (current US$) of Latvia in 1997 to that in 2000?
Your answer should be very brief. 1. What is the ratio of the Aid flow (current US$) in Middle East & North Africa (developing only) in 1997 to that in 2001?
Ensure brevity in your answer.  1.11. What is the ratio of the Aid flow (current US$) of Benin in 1997 to that in 2001?
Keep it short and to the point. 1.42. What is the ratio of the Aid flow (current US$) in Middle East & North Africa (developing only) in 1997 to that in 2002?
Make the answer very short. 1.08. What is the ratio of the Aid flow (current US$) of Benin in 1997 to that in 2002?
Ensure brevity in your answer.  2.62. What is the ratio of the Aid flow (current US$) in Middle East & North Africa (developing only) in 1998 to that in 1999?
Offer a very short reply. 2.12. What is the ratio of the Aid flow (current US$) in Benin in 1998 to that in 1999?
Provide a short and direct response. 0.81. What is the ratio of the Aid flow (current US$) of Middle East & North Africa (developing only) in 1998 to that in 2000?
Give a very brief answer. 3.71. What is the ratio of the Aid flow (current US$) of Benin in 1998 to that in 2000?
Ensure brevity in your answer.  0.9. What is the ratio of the Aid flow (current US$) in Sudan in 1998 to that in 2000?
Make the answer very short. 50. What is the ratio of the Aid flow (current US$) of Middle East & North Africa (developing only) in 1998 to that in 2001?
Make the answer very short. 1.48. What is the ratio of the Aid flow (current US$) of Benin in 1998 to that in 2001?
Your answer should be very brief. 0.73. What is the ratio of the Aid flow (current US$) in Latvia in 1998 to that in 2001?
Provide a succinct answer. 0.5. What is the ratio of the Aid flow (current US$) of Sudan in 1998 to that in 2001?
Your answer should be very brief. 20. What is the ratio of the Aid flow (current US$) of Middle East & North Africa (developing only) in 1998 to that in 2002?
Your answer should be compact. 1.43. What is the ratio of the Aid flow (current US$) of Benin in 1998 to that in 2002?
Provide a succinct answer. 1.34. What is the ratio of the Aid flow (current US$) in Middle East & North Africa (developing only) in 1999 to that in 2000?
Offer a very short reply. 1.75. What is the ratio of the Aid flow (current US$) in Benin in 1999 to that in 2000?
Your response must be concise. 1.1. What is the ratio of the Aid flow (current US$) of Sudan in 1999 to that in 2000?
Offer a very short reply. 1.25. What is the ratio of the Aid flow (current US$) of Middle East & North Africa (developing only) in 1999 to that in 2001?
Provide a succinct answer. 0.7. What is the ratio of the Aid flow (current US$) in Benin in 1999 to that in 2001?
Your answer should be very brief. 0.9. What is the ratio of the Aid flow (current US$) in Latvia in 1999 to that in 2001?
Provide a short and direct response. 0.5. What is the ratio of the Aid flow (current US$) in Sudan in 1999 to that in 2001?
Ensure brevity in your answer.  0.5. What is the ratio of the Aid flow (current US$) of Middle East & North Africa (developing only) in 1999 to that in 2002?
Ensure brevity in your answer.  0.67. What is the ratio of the Aid flow (current US$) of Benin in 1999 to that in 2002?
Ensure brevity in your answer.  1.66. What is the ratio of the Aid flow (current US$) of Middle East & North Africa (developing only) in 2000 to that in 2001?
Provide a succinct answer. 0.4. What is the ratio of the Aid flow (current US$) of Benin in 2000 to that in 2001?
Make the answer very short. 0.81. What is the ratio of the Aid flow (current US$) in Middle East & North Africa (developing only) in 2000 to that in 2002?
Make the answer very short. 0.39. What is the ratio of the Aid flow (current US$) in Middle East & North Africa (developing only) in 2001 to that in 2002?
Your response must be concise. 0.97. What is the ratio of the Aid flow (current US$) of Benin in 2001 to that in 2002?
Provide a succinct answer. 1.84. What is the ratio of the Aid flow (current US$) of Latvia in 2001 to that in 2002?
Keep it short and to the point. 2. What is the difference between the highest and the second highest Aid flow (current US$) in Middle East & North Africa (developing only)?
Make the answer very short. 3.32e+07. What is the difference between the highest and the second highest Aid flow (current US$) in Latvia?
Provide a succinct answer. 10000. What is the difference between the highest and the second highest Aid flow (current US$) in Sudan?
Provide a short and direct response. 1.82e+06. What is the difference between the highest and the lowest Aid flow (current US$) of Middle East & North Africa (developing only)?
Offer a terse response. 9.78e+07. What is the difference between the highest and the lowest Aid flow (current US$) of Benin?
Keep it short and to the point. 6.40e+05. What is the difference between the highest and the lowest Aid flow (current US$) of Latvia?
Ensure brevity in your answer.  10000. What is the difference between the highest and the lowest Aid flow (current US$) of Sudan?
Your response must be concise. 1.99e+06. 